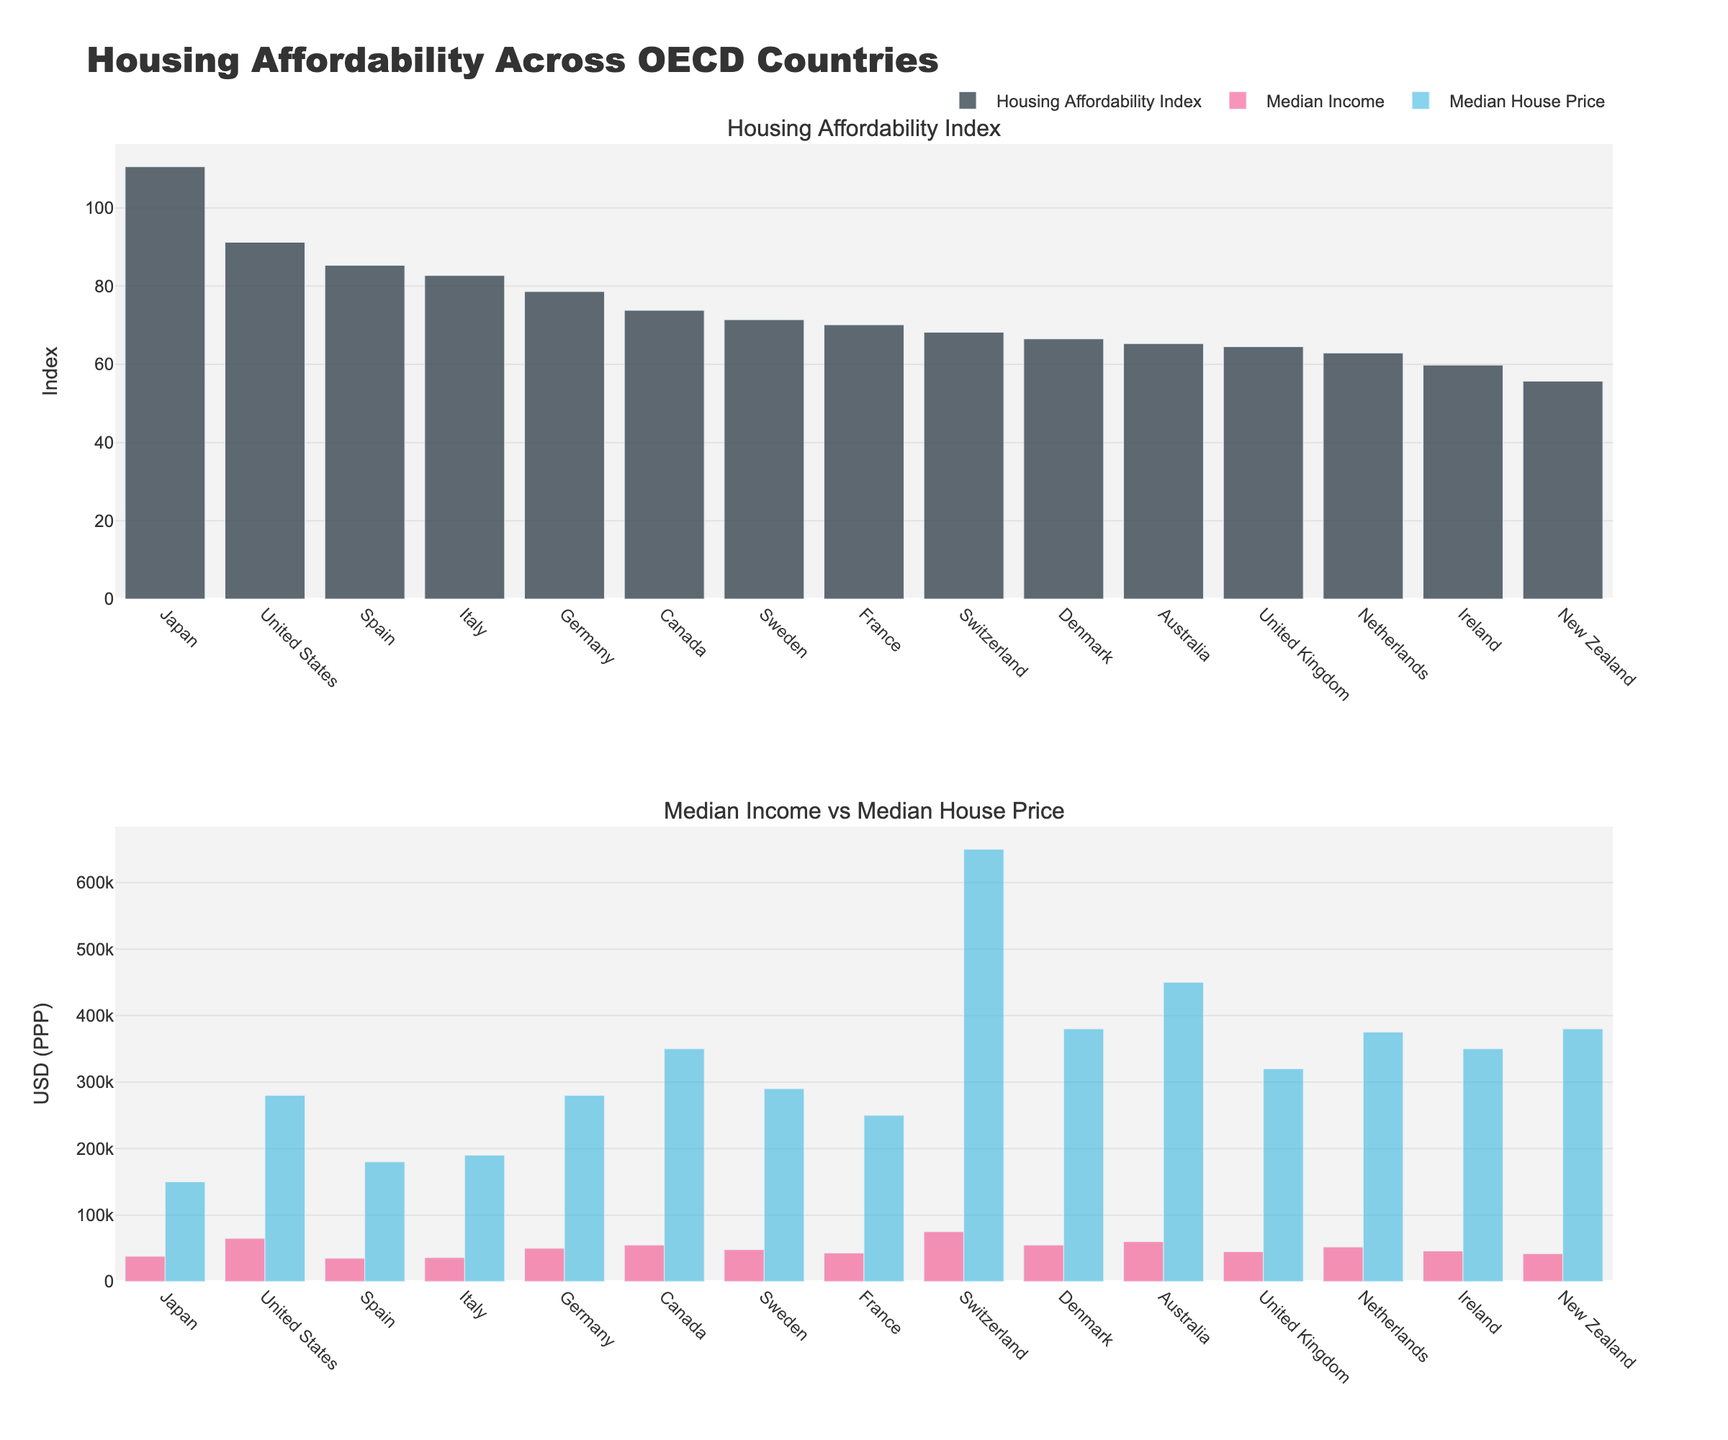what is the country with the highest housing affordability index? To determine the country with the highest housing affordability index, look at the first subplot where the "Housing Affordability Index" bars are sorted in descending order. The first bar represents the country with the highest index.
Answer: Japan What is the median house price for the country with the highest median income? Find the country with the highest median income by looking at the second subplot's "Median Income" bars and select the tallest bar. Then, locate the corresponding bar for "Median House Price" in the same subplot.
Answer: $650,000 Which country has a higher median house price: Canada or Denmark? Locate the bars for median house prices of Canada and Denmark in the second subplot where both bars for "Median Income" and "Median House Price" are present. Compare their heights.
Answer: Denmark what's the difference between the housing affordability index of Australia and New Zealand? Find and read the heights of the Housing Affordability Index bars for Australia and New Zealand from the first subplot. Subtract the smaller index from the larger one.
Answer: 9.6 How many countries have a median income higher than $50,000? Count the number of bars in the "Median Income" section of the second subplot that are taller than the $50,000 mark.
Answer: 5 Which countries have a higher housing affordability index than the United States? Identify the bar for the United States in the Housing Affordability Index subplot. Then, list countries with bars taller than that of the United States.
Answer: Japan, Spain, Italy What's the average median house price of countries with a housing affordability index below 70? Identify countries with a housing affordability index below 70 from the first subplot. Then, add their median house prices from the second subplot and divide by the number of those countries. The relevant countries are United Kingdom, Australia, Netherlands, New Zealand, Ireland. Their median house prices are 320,000 + 450,000 + 375,000 + 380,000 + 350,000 respectively. Sum is 1,875,000. Divide by 5 (1,875,000 / 5).
Answer: $375,000 